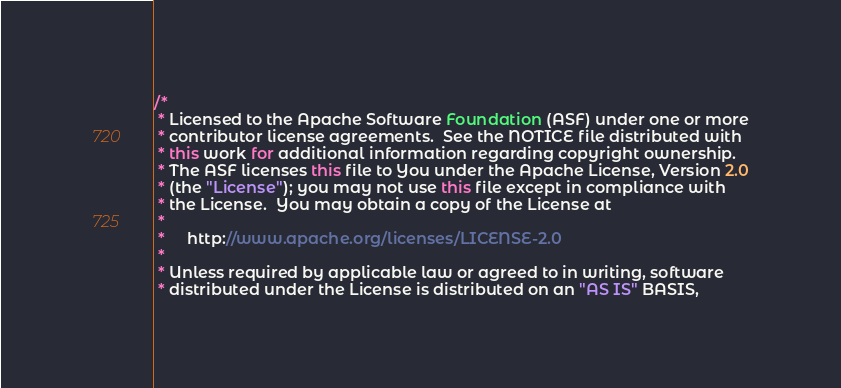Convert code to text. <code><loc_0><loc_0><loc_500><loc_500><_Java_>/*
 * Licensed to the Apache Software Foundation (ASF) under one or more
 * contributor license agreements.  See the NOTICE file distributed with
 * this work for additional information regarding copyright ownership.
 * The ASF licenses this file to You under the Apache License, Version 2.0
 * (the "License"); you may not use this file except in compliance with
 * the License.  You may obtain a copy of the License at
 *
 *     http://www.apache.org/licenses/LICENSE-2.0
 *
 * Unless required by applicable law or agreed to in writing, software
 * distributed under the License is distributed on an "AS IS" BASIS,</code> 